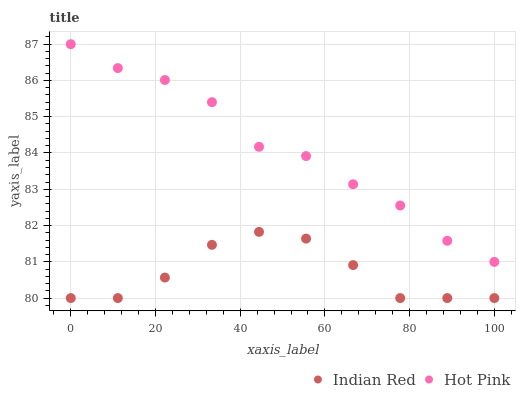Does Indian Red have the minimum area under the curve?
Answer yes or no. Yes. Does Hot Pink have the maximum area under the curve?
Answer yes or no. Yes. Does Indian Red have the maximum area under the curve?
Answer yes or no. No. Is Indian Red the smoothest?
Answer yes or no. Yes. Is Hot Pink the roughest?
Answer yes or no. Yes. Is Indian Red the roughest?
Answer yes or no. No. Does Indian Red have the lowest value?
Answer yes or no. Yes. Does Hot Pink have the highest value?
Answer yes or no. Yes. Does Indian Red have the highest value?
Answer yes or no. No. Is Indian Red less than Hot Pink?
Answer yes or no. Yes. Is Hot Pink greater than Indian Red?
Answer yes or no. Yes. Does Indian Red intersect Hot Pink?
Answer yes or no. No. 